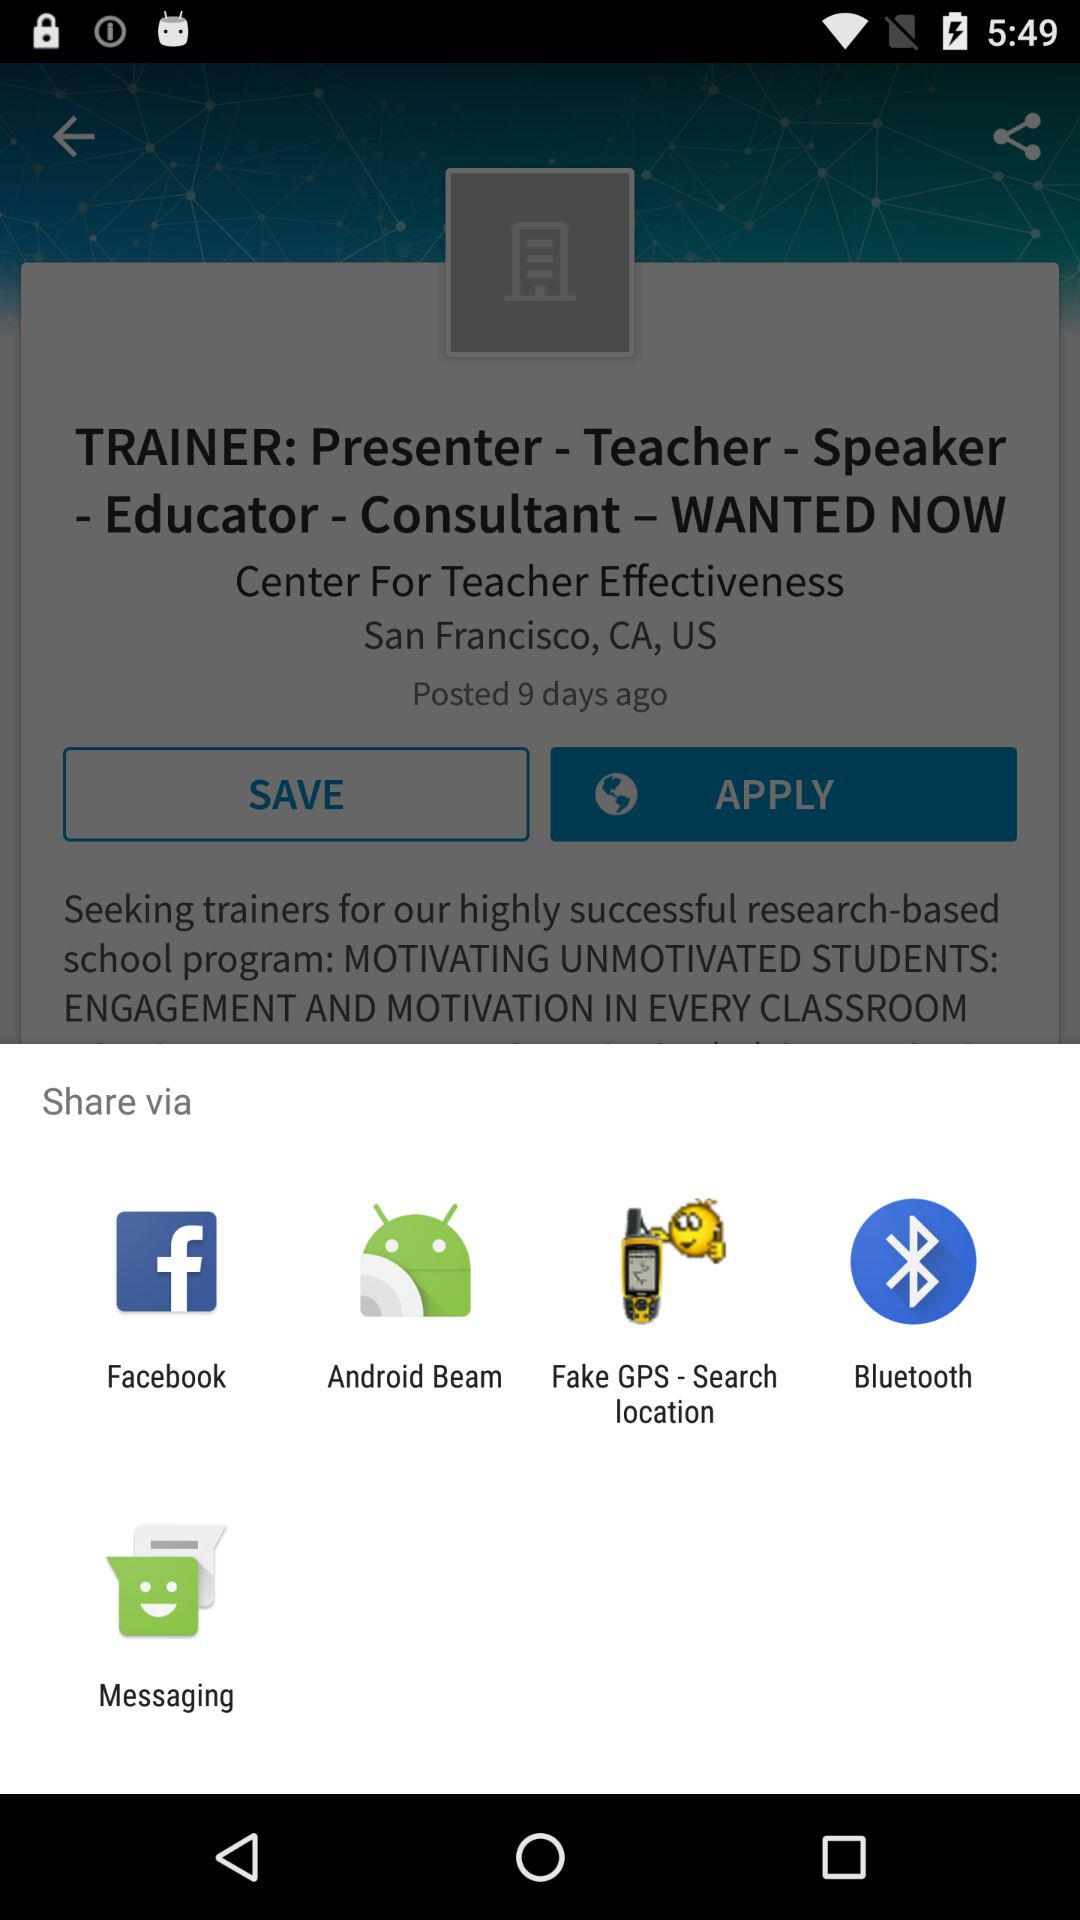What is the current location?
When the provided information is insufficient, respond with <no answer>. <no answer> 